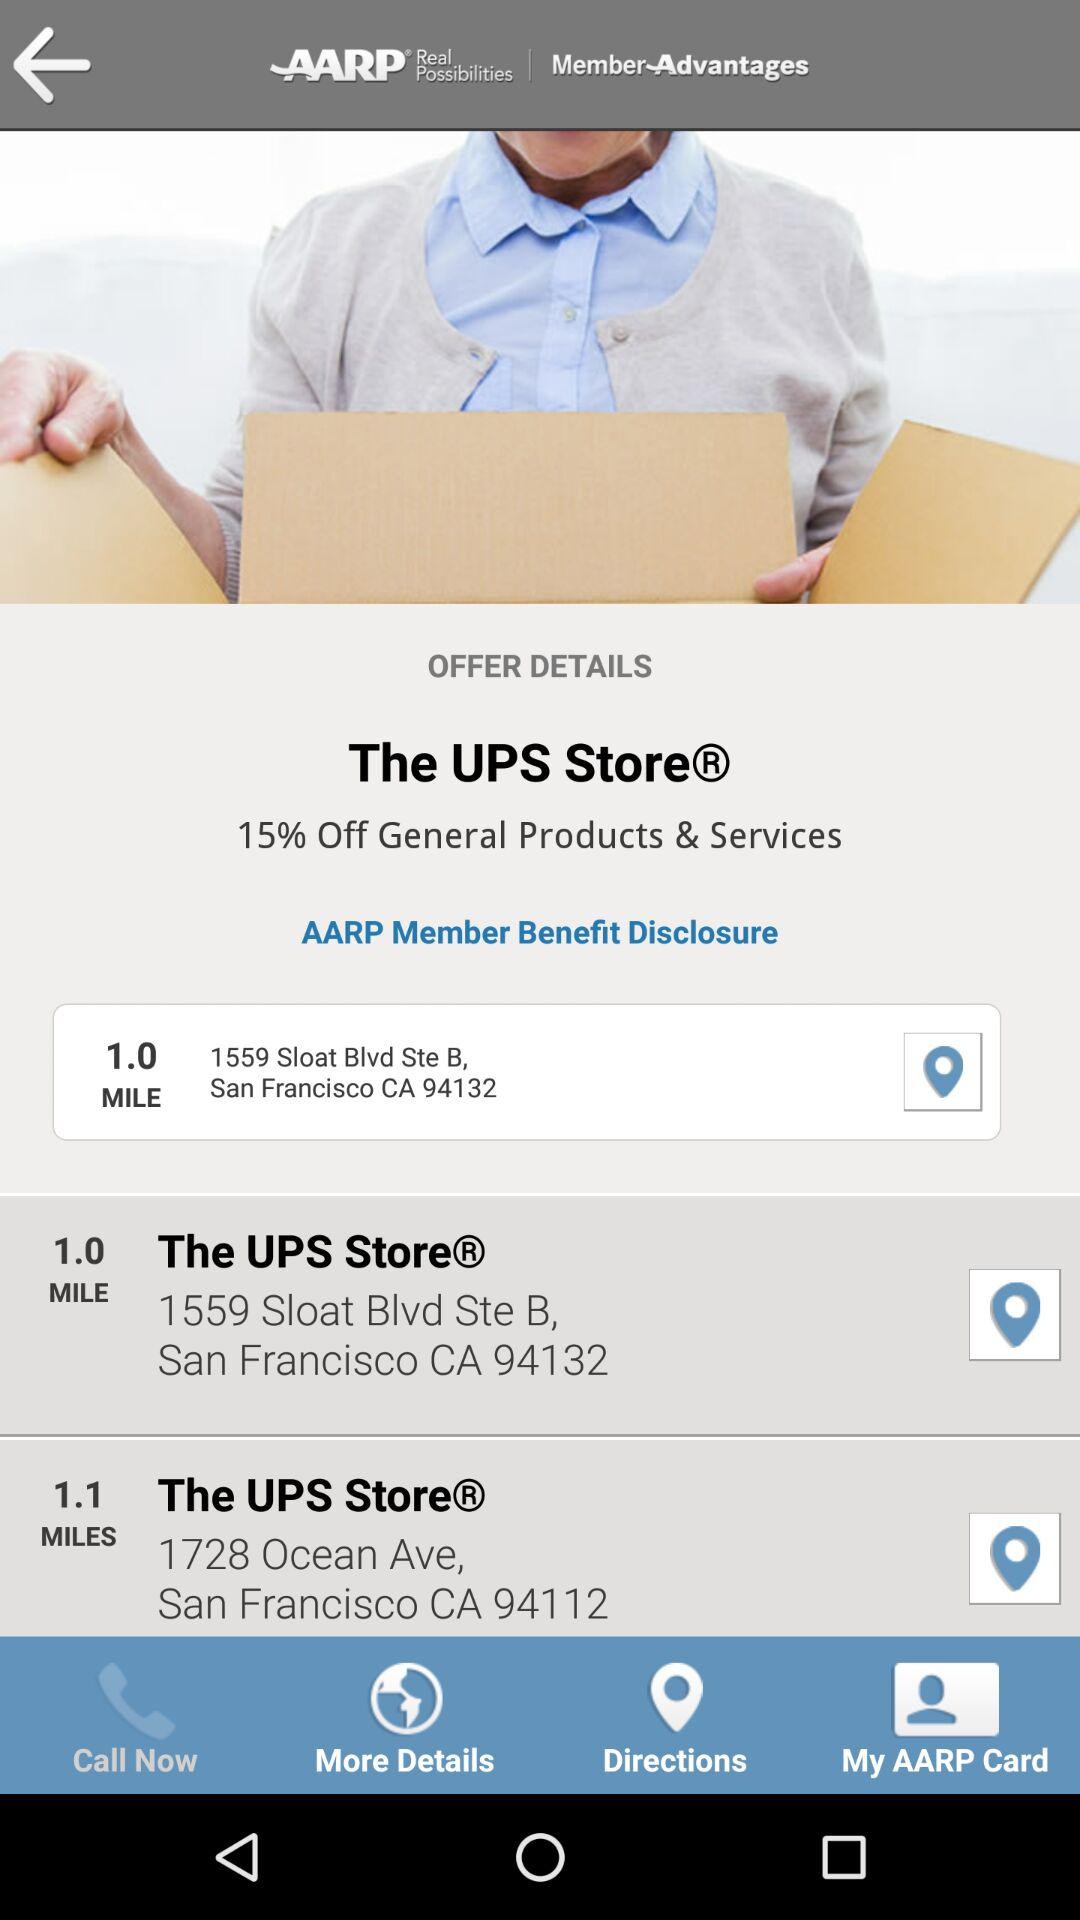What is the location of the UPS Store, which is 1.0 mile away? The UPS Store, which is 1.0 mile away, is located at 1559 Sloat Blvd, Ste B, San Francisco, CA 94132. 